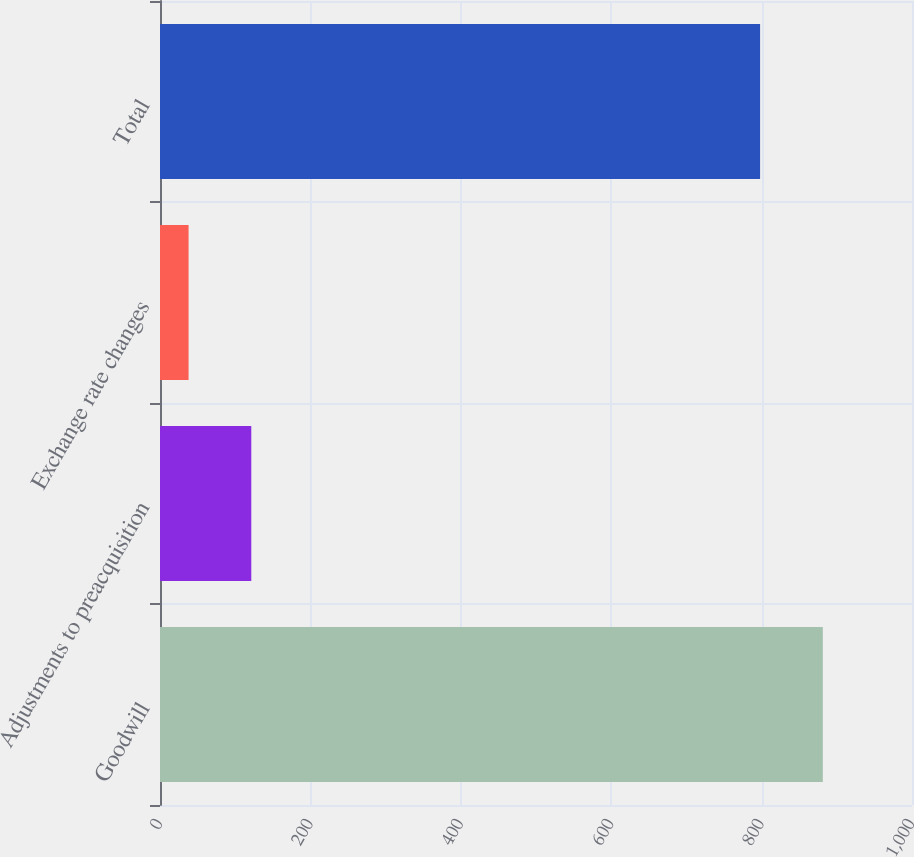Convert chart. <chart><loc_0><loc_0><loc_500><loc_500><bar_chart><fcel>Goodwill<fcel>Adjustments to preacquisition<fcel>Exchange rate changes<fcel>Total<nl><fcel>881.4<fcel>121.4<fcel>38<fcel>798<nl></chart> 